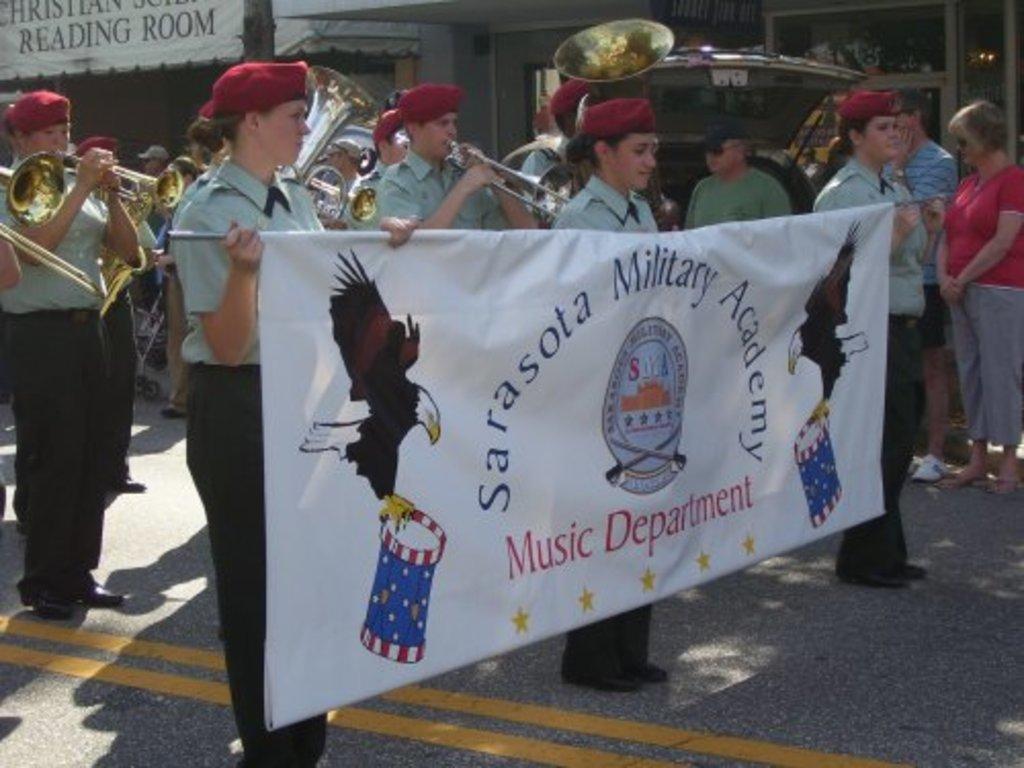How would you summarize this image in a sentence or two? In the foreground of this image, there are three women holding a banner and standing on the road. In the background, there are persons standing and few are playing trumpets and in the background, there are two buildings. 